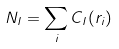Convert formula to latex. <formula><loc_0><loc_0><loc_500><loc_500>N _ { I } = \sum _ { i } C _ { I } ( r _ { i } )</formula> 